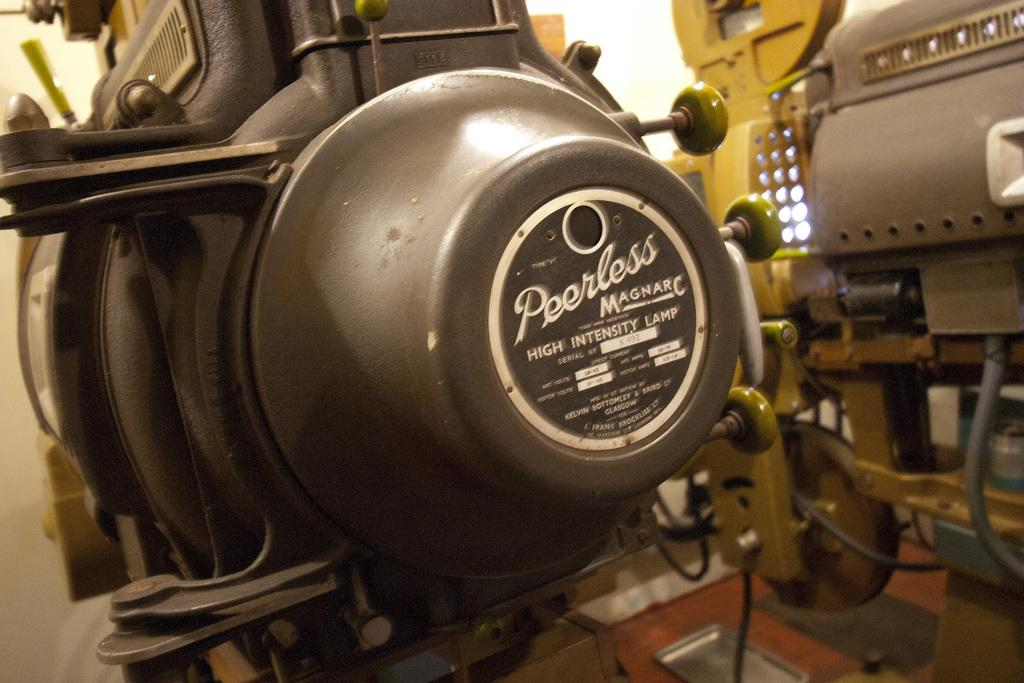What can be seen in the image? There are machines in the image. What is located behind the machines? There is a wall behind the machines in the image. How many wrens are sitting on the machines in the image? There are no wrens present in the image. What type of things can be seen flying around the machines in the image? There are no things flying around the machines in the image. 